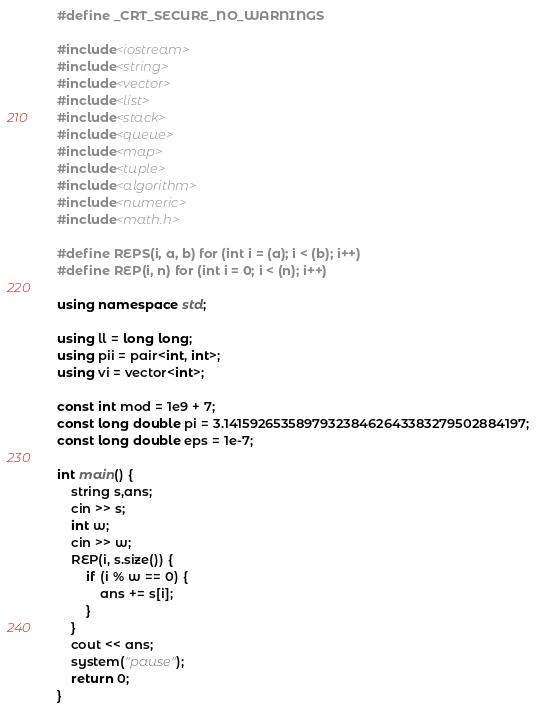Convert code to text. <code><loc_0><loc_0><loc_500><loc_500><_C++_>#define _CRT_SECURE_NO_WARNINGS

#include<iostream>
#include<string>
#include<vector>
#include<list>
#include<stack>
#include<queue>
#include<map>
#include<tuple>
#include<algorithm>
#include<numeric>
#include<math.h>

#define REPS(i, a, b) for (int i = (a); i < (b); i++)
#define REP(i, n) for (int i = 0; i < (n); i++)

using namespace std;

using ll = long long;
using pii = pair<int, int>;
using vi = vector<int>;

const int mod = 1e9 + 7;
const long double pi = 3.141592653589793238462643383279502884197;
const long double eps = 1e-7;

int main() {
	string s,ans;
	cin >> s;
	int w;
	cin >> w;
	REP(i, s.size()) {
		if (i % w == 0) {
			ans += s[i];
		}
	}
	cout << ans;
	system("pause");
	return 0;
}</code> 